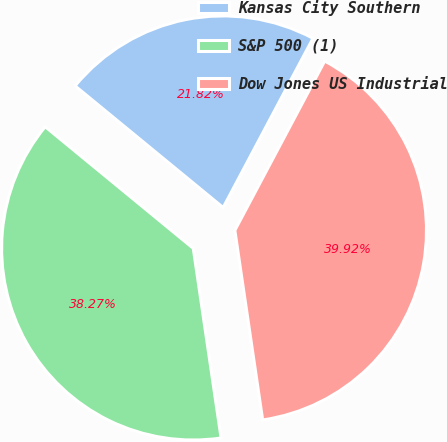Convert chart to OTSL. <chart><loc_0><loc_0><loc_500><loc_500><pie_chart><fcel>Kansas City Southern<fcel>S&P 500 (1)<fcel>Dow Jones US Industrial<nl><fcel>21.82%<fcel>38.27%<fcel>39.92%<nl></chart> 